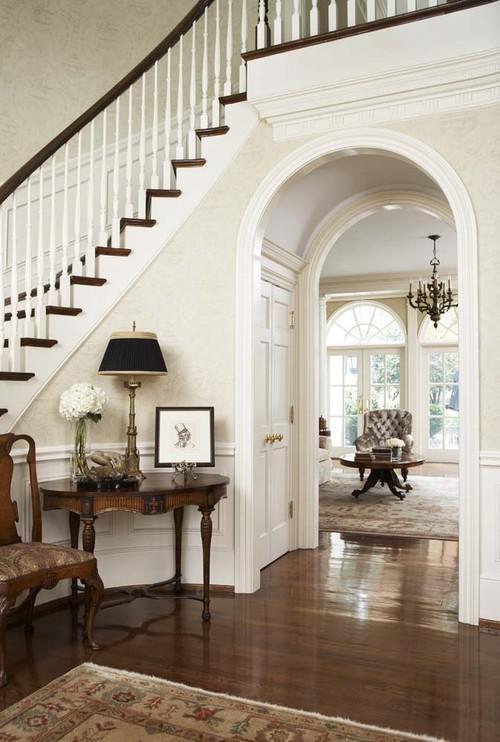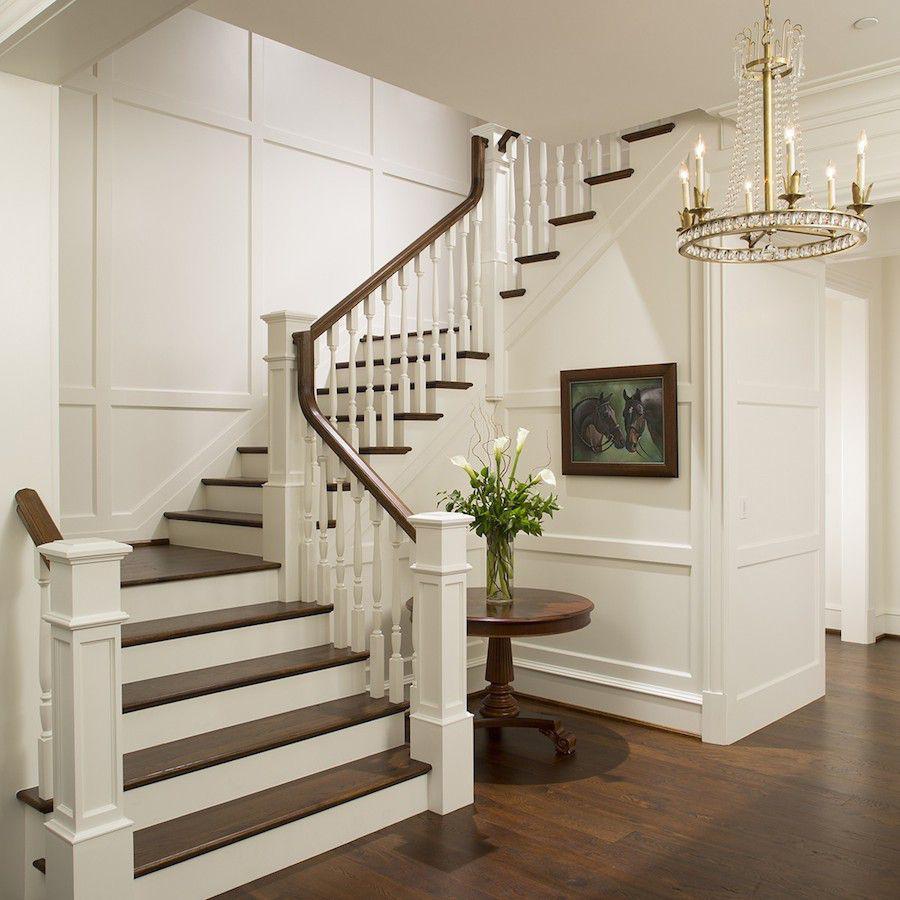The first image is the image on the left, the second image is the image on the right. For the images displayed, is the sentence "One image shows a staircase that curves to the left as it descends and has brown steps with white base boards and a black handrail." factually correct? Answer yes or no. No. The first image is the image on the left, the second image is the image on the right. For the images displayed, is the sentence "There is at least one vase with white flowers in it sitting on a table." factually correct? Answer yes or no. Yes. 